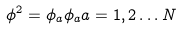Convert formula to latex. <formula><loc_0><loc_0><loc_500><loc_500>\phi ^ { 2 } = \phi _ { a } \phi _ { a } a = 1 , 2 \dots N</formula> 